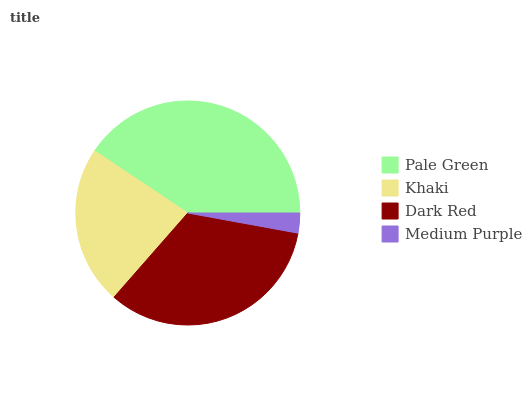Is Medium Purple the minimum?
Answer yes or no. Yes. Is Pale Green the maximum?
Answer yes or no. Yes. Is Khaki the minimum?
Answer yes or no. No. Is Khaki the maximum?
Answer yes or no. No. Is Pale Green greater than Khaki?
Answer yes or no. Yes. Is Khaki less than Pale Green?
Answer yes or no. Yes. Is Khaki greater than Pale Green?
Answer yes or no. No. Is Pale Green less than Khaki?
Answer yes or no. No. Is Dark Red the high median?
Answer yes or no. Yes. Is Khaki the low median?
Answer yes or no. Yes. Is Pale Green the high median?
Answer yes or no. No. Is Pale Green the low median?
Answer yes or no. No. 